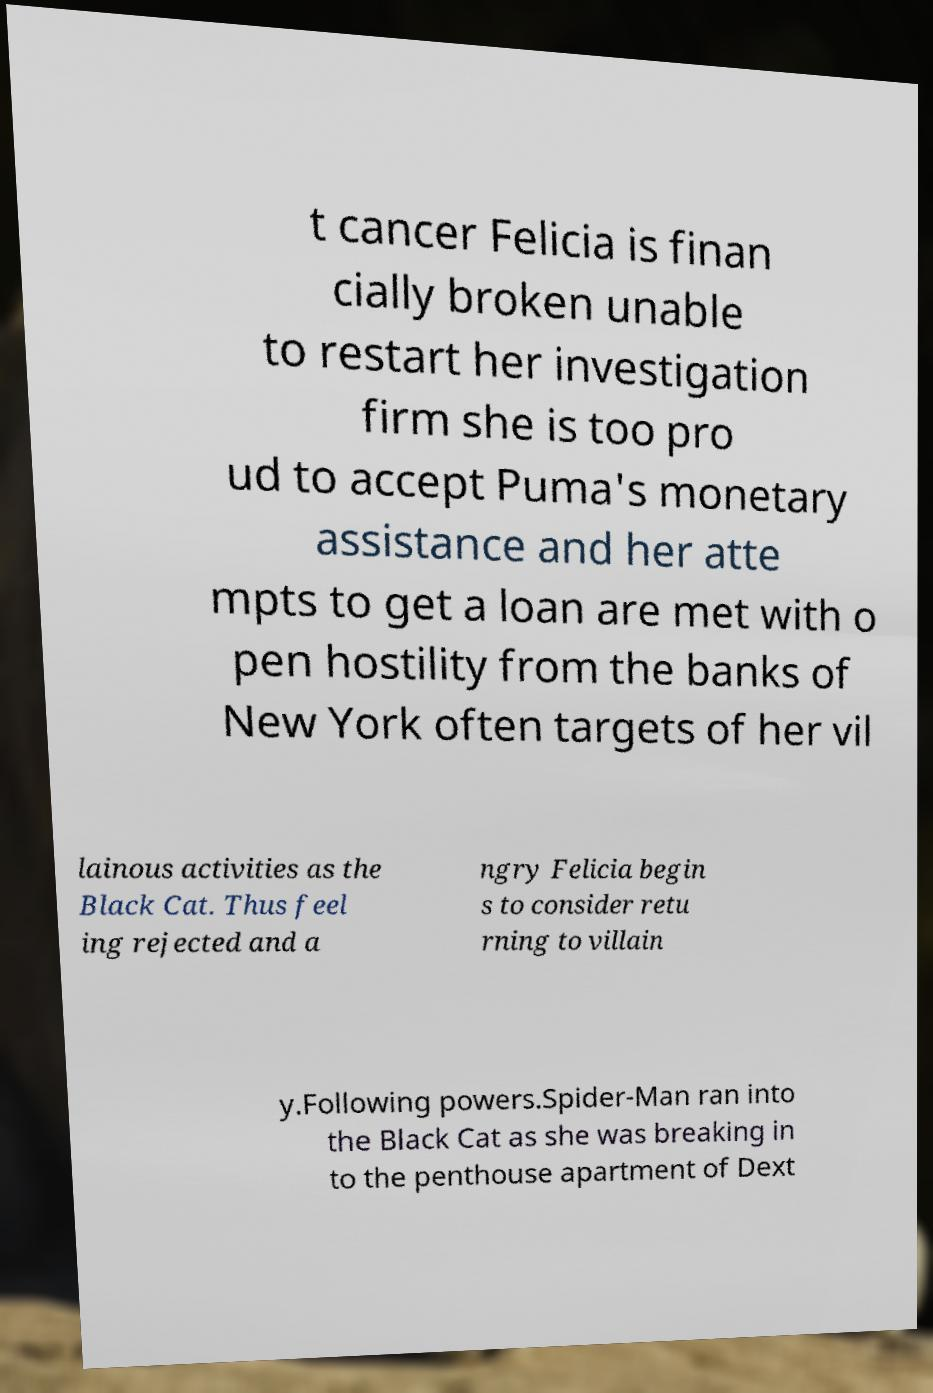Please read and relay the text visible in this image. What does it say? t cancer Felicia is finan cially broken unable to restart her investigation firm she is too pro ud to accept Puma's monetary assistance and her atte mpts to get a loan are met with o pen hostility from the banks of New York often targets of her vil lainous activities as the Black Cat. Thus feel ing rejected and a ngry Felicia begin s to consider retu rning to villain y.Following powers.Spider-Man ran into the Black Cat as she was breaking in to the penthouse apartment of Dext 